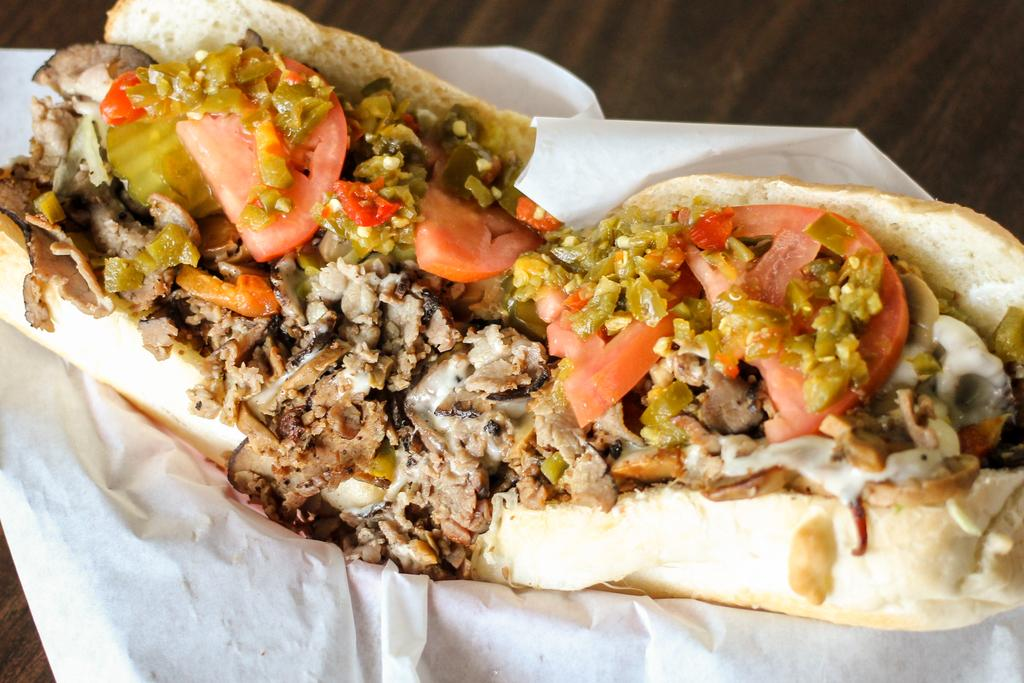What type of furniture is present in the image? There is a table in the image. What is placed on the table? There is tissue on the table. What is on top of the tissue? There is a food item on the tissue. What is the condition of the spark in the image? There is no spark present in the image. 